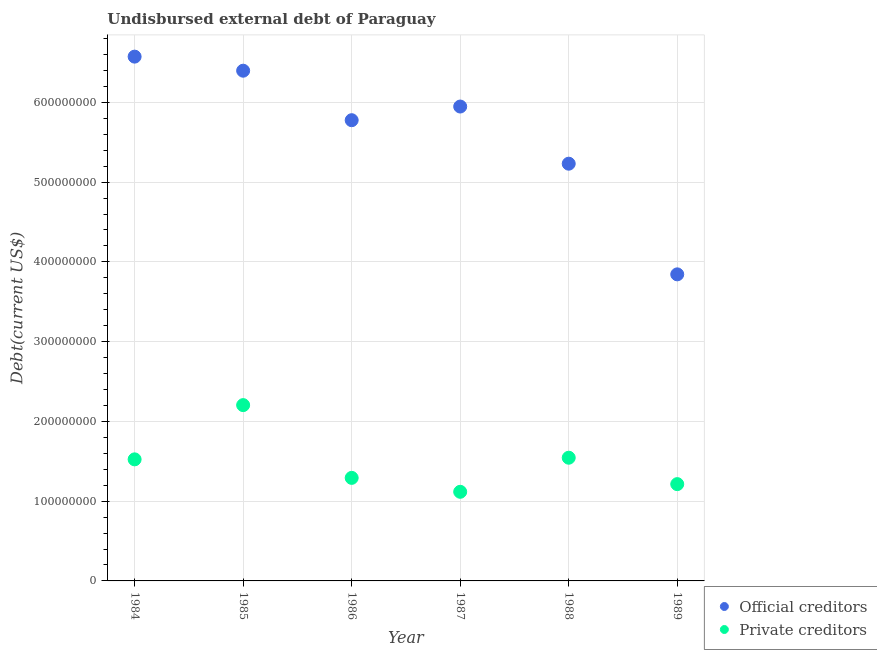How many different coloured dotlines are there?
Provide a succinct answer. 2. Is the number of dotlines equal to the number of legend labels?
Your answer should be compact. Yes. What is the undisbursed external debt of official creditors in 1986?
Offer a very short reply. 5.78e+08. Across all years, what is the maximum undisbursed external debt of official creditors?
Your response must be concise. 6.57e+08. Across all years, what is the minimum undisbursed external debt of official creditors?
Offer a very short reply. 3.84e+08. In which year was the undisbursed external debt of official creditors maximum?
Make the answer very short. 1984. What is the total undisbursed external debt of private creditors in the graph?
Your answer should be very brief. 8.90e+08. What is the difference between the undisbursed external debt of private creditors in 1985 and that in 1989?
Offer a very short reply. 9.91e+07. What is the difference between the undisbursed external debt of private creditors in 1989 and the undisbursed external debt of official creditors in 1987?
Your response must be concise. -4.73e+08. What is the average undisbursed external debt of private creditors per year?
Your answer should be compact. 1.48e+08. In the year 1989, what is the difference between the undisbursed external debt of official creditors and undisbursed external debt of private creditors?
Your answer should be compact. 2.63e+08. What is the ratio of the undisbursed external debt of private creditors in 1985 to that in 1989?
Provide a short and direct response. 1.82. Is the undisbursed external debt of private creditors in 1984 less than that in 1988?
Provide a short and direct response. Yes. What is the difference between the highest and the second highest undisbursed external debt of private creditors?
Make the answer very short. 6.60e+07. What is the difference between the highest and the lowest undisbursed external debt of private creditors?
Keep it short and to the point. 1.09e+08. In how many years, is the undisbursed external debt of private creditors greater than the average undisbursed external debt of private creditors taken over all years?
Keep it short and to the point. 3. Does the undisbursed external debt of private creditors monotonically increase over the years?
Offer a very short reply. No. Is the undisbursed external debt of private creditors strictly greater than the undisbursed external debt of official creditors over the years?
Provide a succinct answer. No. How many dotlines are there?
Provide a succinct answer. 2. How many years are there in the graph?
Keep it short and to the point. 6. What is the difference between two consecutive major ticks on the Y-axis?
Your answer should be compact. 1.00e+08. Are the values on the major ticks of Y-axis written in scientific E-notation?
Make the answer very short. No. How many legend labels are there?
Your answer should be compact. 2. What is the title of the graph?
Offer a terse response. Undisbursed external debt of Paraguay. Does "Registered firms" appear as one of the legend labels in the graph?
Keep it short and to the point. No. What is the label or title of the Y-axis?
Ensure brevity in your answer.  Debt(current US$). What is the Debt(current US$) of Official creditors in 1984?
Offer a very short reply. 6.57e+08. What is the Debt(current US$) in Private creditors in 1984?
Offer a terse response. 1.52e+08. What is the Debt(current US$) in Official creditors in 1985?
Your answer should be compact. 6.40e+08. What is the Debt(current US$) in Private creditors in 1985?
Give a very brief answer. 2.20e+08. What is the Debt(current US$) in Official creditors in 1986?
Offer a terse response. 5.78e+08. What is the Debt(current US$) of Private creditors in 1986?
Ensure brevity in your answer.  1.29e+08. What is the Debt(current US$) in Official creditors in 1987?
Make the answer very short. 5.95e+08. What is the Debt(current US$) of Private creditors in 1987?
Provide a short and direct response. 1.12e+08. What is the Debt(current US$) in Official creditors in 1988?
Provide a succinct answer. 5.23e+08. What is the Debt(current US$) in Private creditors in 1988?
Give a very brief answer. 1.54e+08. What is the Debt(current US$) of Official creditors in 1989?
Your answer should be compact. 3.84e+08. What is the Debt(current US$) of Private creditors in 1989?
Give a very brief answer. 1.21e+08. Across all years, what is the maximum Debt(current US$) in Official creditors?
Provide a succinct answer. 6.57e+08. Across all years, what is the maximum Debt(current US$) in Private creditors?
Keep it short and to the point. 2.20e+08. Across all years, what is the minimum Debt(current US$) in Official creditors?
Your response must be concise. 3.84e+08. Across all years, what is the minimum Debt(current US$) in Private creditors?
Your answer should be very brief. 1.12e+08. What is the total Debt(current US$) in Official creditors in the graph?
Your answer should be compact. 3.38e+09. What is the total Debt(current US$) of Private creditors in the graph?
Offer a terse response. 8.90e+08. What is the difference between the Debt(current US$) of Official creditors in 1984 and that in 1985?
Offer a very short reply. 1.76e+07. What is the difference between the Debt(current US$) in Private creditors in 1984 and that in 1985?
Provide a short and direct response. -6.80e+07. What is the difference between the Debt(current US$) in Official creditors in 1984 and that in 1986?
Ensure brevity in your answer.  7.97e+07. What is the difference between the Debt(current US$) of Private creditors in 1984 and that in 1986?
Keep it short and to the point. 2.32e+07. What is the difference between the Debt(current US$) of Official creditors in 1984 and that in 1987?
Your answer should be compact. 6.26e+07. What is the difference between the Debt(current US$) in Private creditors in 1984 and that in 1987?
Offer a very short reply. 4.07e+07. What is the difference between the Debt(current US$) in Official creditors in 1984 and that in 1988?
Your answer should be very brief. 1.34e+08. What is the difference between the Debt(current US$) of Private creditors in 1984 and that in 1988?
Give a very brief answer. -2.04e+06. What is the difference between the Debt(current US$) in Official creditors in 1984 and that in 1989?
Provide a succinct answer. 2.73e+08. What is the difference between the Debt(current US$) of Private creditors in 1984 and that in 1989?
Offer a terse response. 3.11e+07. What is the difference between the Debt(current US$) of Official creditors in 1985 and that in 1986?
Provide a short and direct response. 6.21e+07. What is the difference between the Debt(current US$) of Private creditors in 1985 and that in 1986?
Provide a succinct answer. 9.12e+07. What is the difference between the Debt(current US$) of Official creditors in 1985 and that in 1987?
Make the answer very short. 4.49e+07. What is the difference between the Debt(current US$) of Private creditors in 1985 and that in 1987?
Provide a succinct answer. 1.09e+08. What is the difference between the Debt(current US$) in Official creditors in 1985 and that in 1988?
Ensure brevity in your answer.  1.17e+08. What is the difference between the Debt(current US$) in Private creditors in 1985 and that in 1988?
Offer a very short reply. 6.60e+07. What is the difference between the Debt(current US$) in Official creditors in 1985 and that in 1989?
Give a very brief answer. 2.55e+08. What is the difference between the Debt(current US$) of Private creditors in 1985 and that in 1989?
Your response must be concise. 9.91e+07. What is the difference between the Debt(current US$) in Official creditors in 1986 and that in 1987?
Offer a very short reply. -1.71e+07. What is the difference between the Debt(current US$) in Private creditors in 1986 and that in 1987?
Your response must be concise. 1.75e+07. What is the difference between the Debt(current US$) of Official creditors in 1986 and that in 1988?
Provide a short and direct response. 5.45e+07. What is the difference between the Debt(current US$) in Private creditors in 1986 and that in 1988?
Make the answer very short. -2.53e+07. What is the difference between the Debt(current US$) in Official creditors in 1986 and that in 1989?
Provide a short and direct response. 1.93e+08. What is the difference between the Debt(current US$) in Private creditors in 1986 and that in 1989?
Offer a terse response. 7.84e+06. What is the difference between the Debt(current US$) of Official creditors in 1987 and that in 1988?
Offer a terse response. 7.17e+07. What is the difference between the Debt(current US$) in Private creditors in 1987 and that in 1988?
Provide a short and direct response. -4.27e+07. What is the difference between the Debt(current US$) in Official creditors in 1987 and that in 1989?
Your answer should be compact. 2.10e+08. What is the difference between the Debt(current US$) of Private creditors in 1987 and that in 1989?
Give a very brief answer. -9.62e+06. What is the difference between the Debt(current US$) in Official creditors in 1988 and that in 1989?
Your answer should be very brief. 1.39e+08. What is the difference between the Debt(current US$) in Private creditors in 1988 and that in 1989?
Offer a terse response. 3.31e+07. What is the difference between the Debt(current US$) in Official creditors in 1984 and the Debt(current US$) in Private creditors in 1985?
Make the answer very short. 4.37e+08. What is the difference between the Debt(current US$) in Official creditors in 1984 and the Debt(current US$) in Private creditors in 1986?
Your answer should be compact. 5.28e+08. What is the difference between the Debt(current US$) in Official creditors in 1984 and the Debt(current US$) in Private creditors in 1987?
Provide a short and direct response. 5.46e+08. What is the difference between the Debt(current US$) in Official creditors in 1984 and the Debt(current US$) in Private creditors in 1988?
Give a very brief answer. 5.03e+08. What is the difference between the Debt(current US$) in Official creditors in 1984 and the Debt(current US$) in Private creditors in 1989?
Your answer should be compact. 5.36e+08. What is the difference between the Debt(current US$) of Official creditors in 1985 and the Debt(current US$) of Private creditors in 1986?
Your answer should be compact. 5.10e+08. What is the difference between the Debt(current US$) of Official creditors in 1985 and the Debt(current US$) of Private creditors in 1987?
Offer a very short reply. 5.28e+08. What is the difference between the Debt(current US$) in Official creditors in 1985 and the Debt(current US$) in Private creditors in 1988?
Ensure brevity in your answer.  4.85e+08. What is the difference between the Debt(current US$) in Official creditors in 1985 and the Debt(current US$) in Private creditors in 1989?
Your response must be concise. 5.18e+08. What is the difference between the Debt(current US$) in Official creditors in 1986 and the Debt(current US$) in Private creditors in 1987?
Make the answer very short. 4.66e+08. What is the difference between the Debt(current US$) in Official creditors in 1986 and the Debt(current US$) in Private creditors in 1988?
Your response must be concise. 4.23e+08. What is the difference between the Debt(current US$) of Official creditors in 1986 and the Debt(current US$) of Private creditors in 1989?
Provide a short and direct response. 4.56e+08. What is the difference between the Debt(current US$) of Official creditors in 1987 and the Debt(current US$) of Private creditors in 1988?
Your response must be concise. 4.40e+08. What is the difference between the Debt(current US$) of Official creditors in 1987 and the Debt(current US$) of Private creditors in 1989?
Ensure brevity in your answer.  4.73e+08. What is the difference between the Debt(current US$) of Official creditors in 1988 and the Debt(current US$) of Private creditors in 1989?
Keep it short and to the point. 4.02e+08. What is the average Debt(current US$) of Official creditors per year?
Your response must be concise. 5.63e+08. What is the average Debt(current US$) of Private creditors per year?
Your response must be concise. 1.48e+08. In the year 1984, what is the difference between the Debt(current US$) of Official creditors and Debt(current US$) of Private creditors?
Your response must be concise. 5.05e+08. In the year 1985, what is the difference between the Debt(current US$) in Official creditors and Debt(current US$) in Private creditors?
Provide a short and direct response. 4.19e+08. In the year 1986, what is the difference between the Debt(current US$) of Official creditors and Debt(current US$) of Private creditors?
Offer a very short reply. 4.48e+08. In the year 1987, what is the difference between the Debt(current US$) of Official creditors and Debt(current US$) of Private creditors?
Ensure brevity in your answer.  4.83e+08. In the year 1988, what is the difference between the Debt(current US$) of Official creditors and Debt(current US$) of Private creditors?
Make the answer very short. 3.69e+08. In the year 1989, what is the difference between the Debt(current US$) of Official creditors and Debt(current US$) of Private creditors?
Make the answer very short. 2.63e+08. What is the ratio of the Debt(current US$) of Official creditors in 1984 to that in 1985?
Provide a short and direct response. 1.03. What is the ratio of the Debt(current US$) of Private creditors in 1984 to that in 1985?
Your response must be concise. 0.69. What is the ratio of the Debt(current US$) of Official creditors in 1984 to that in 1986?
Keep it short and to the point. 1.14. What is the ratio of the Debt(current US$) of Private creditors in 1984 to that in 1986?
Your answer should be very brief. 1.18. What is the ratio of the Debt(current US$) in Official creditors in 1984 to that in 1987?
Give a very brief answer. 1.11. What is the ratio of the Debt(current US$) in Private creditors in 1984 to that in 1987?
Offer a terse response. 1.36. What is the ratio of the Debt(current US$) of Official creditors in 1984 to that in 1988?
Offer a very short reply. 1.26. What is the ratio of the Debt(current US$) in Official creditors in 1984 to that in 1989?
Keep it short and to the point. 1.71. What is the ratio of the Debt(current US$) in Private creditors in 1984 to that in 1989?
Offer a very short reply. 1.26. What is the ratio of the Debt(current US$) of Official creditors in 1985 to that in 1986?
Ensure brevity in your answer.  1.11. What is the ratio of the Debt(current US$) in Private creditors in 1985 to that in 1986?
Your answer should be very brief. 1.71. What is the ratio of the Debt(current US$) of Official creditors in 1985 to that in 1987?
Ensure brevity in your answer.  1.08. What is the ratio of the Debt(current US$) in Private creditors in 1985 to that in 1987?
Your response must be concise. 1.97. What is the ratio of the Debt(current US$) in Official creditors in 1985 to that in 1988?
Give a very brief answer. 1.22. What is the ratio of the Debt(current US$) of Private creditors in 1985 to that in 1988?
Make the answer very short. 1.43. What is the ratio of the Debt(current US$) of Official creditors in 1985 to that in 1989?
Your response must be concise. 1.66. What is the ratio of the Debt(current US$) of Private creditors in 1985 to that in 1989?
Make the answer very short. 1.82. What is the ratio of the Debt(current US$) of Official creditors in 1986 to that in 1987?
Offer a terse response. 0.97. What is the ratio of the Debt(current US$) in Private creditors in 1986 to that in 1987?
Your answer should be compact. 1.16. What is the ratio of the Debt(current US$) of Official creditors in 1986 to that in 1988?
Give a very brief answer. 1.1. What is the ratio of the Debt(current US$) of Private creditors in 1986 to that in 1988?
Make the answer very short. 0.84. What is the ratio of the Debt(current US$) in Official creditors in 1986 to that in 1989?
Your response must be concise. 1.5. What is the ratio of the Debt(current US$) of Private creditors in 1986 to that in 1989?
Give a very brief answer. 1.06. What is the ratio of the Debt(current US$) in Official creditors in 1987 to that in 1988?
Provide a short and direct response. 1.14. What is the ratio of the Debt(current US$) of Private creditors in 1987 to that in 1988?
Offer a terse response. 0.72. What is the ratio of the Debt(current US$) of Official creditors in 1987 to that in 1989?
Your response must be concise. 1.55. What is the ratio of the Debt(current US$) in Private creditors in 1987 to that in 1989?
Provide a short and direct response. 0.92. What is the ratio of the Debt(current US$) in Official creditors in 1988 to that in 1989?
Provide a succinct answer. 1.36. What is the ratio of the Debt(current US$) in Private creditors in 1988 to that in 1989?
Give a very brief answer. 1.27. What is the difference between the highest and the second highest Debt(current US$) in Official creditors?
Your response must be concise. 1.76e+07. What is the difference between the highest and the second highest Debt(current US$) in Private creditors?
Your answer should be compact. 6.60e+07. What is the difference between the highest and the lowest Debt(current US$) in Official creditors?
Your answer should be very brief. 2.73e+08. What is the difference between the highest and the lowest Debt(current US$) in Private creditors?
Offer a terse response. 1.09e+08. 